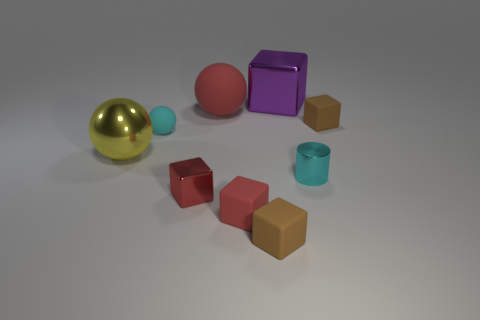Subtract all brown rubber cubes. How many cubes are left? 3 Subtract 1 cylinders. How many cylinders are left? 0 Add 1 large metallic things. How many objects exist? 10 Subtract all spheres. How many objects are left? 6 Subtract all red cubes. How many cubes are left? 3 Subtract all small green shiny balls. Subtract all tiny brown cubes. How many objects are left? 7 Add 8 small cyan metal cylinders. How many small cyan metal cylinders are left? 9 Add 3 large purple blocks. How many large purple blocks exist? 4 Subtract 0 yellow cylinders. How many objects are left? 9 Subtract all red spheres. Subtract all blue blocks. How many spheres are left? 2 